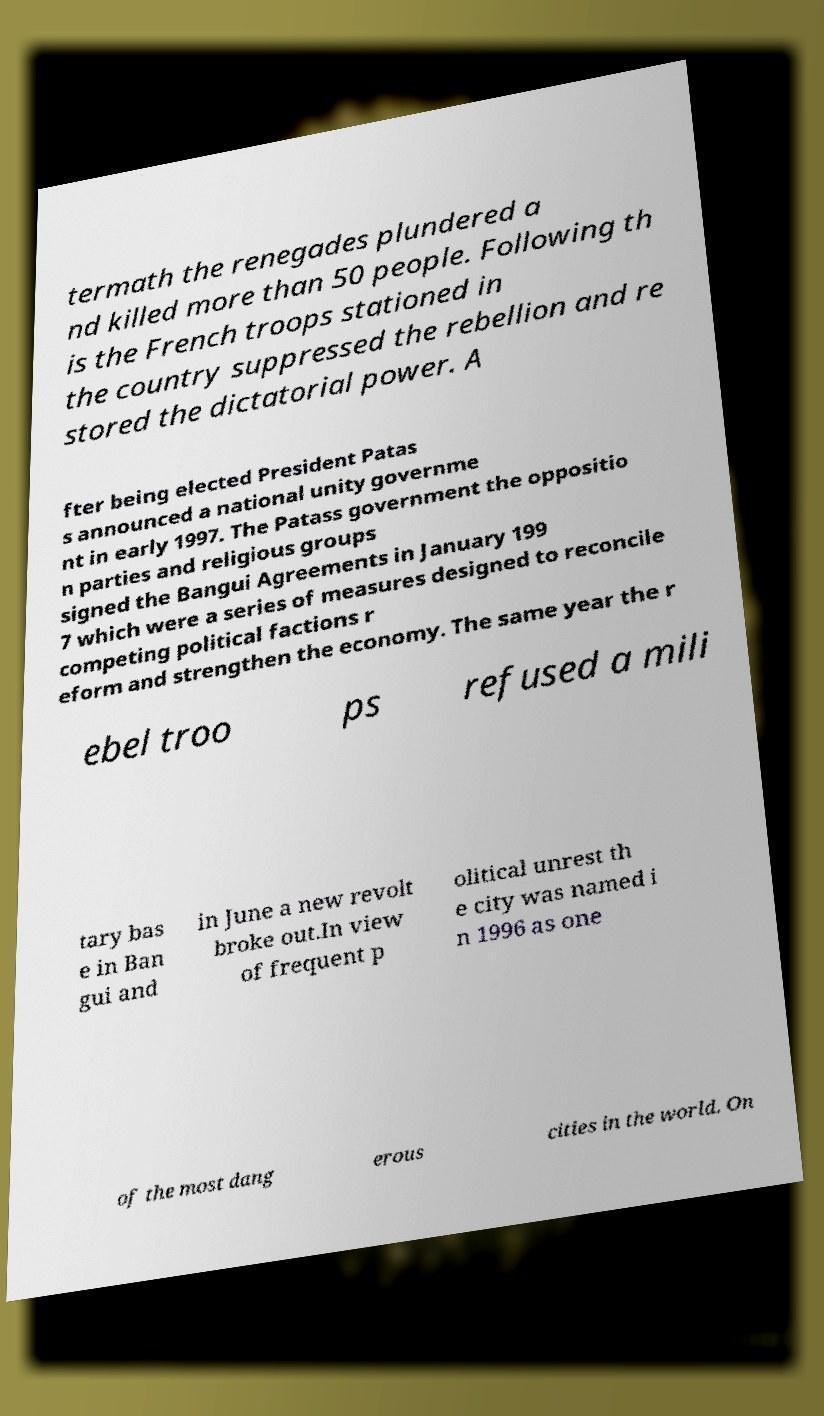There's text embedded in this image that I need extracted. Can you transcribe it verbatim? termath the renegades plundered a nd killed more than 50 people. Following th is the French troops stationed in the country suppressed the rebellion and re stored the dictatorial power. A fter being elected President Patas s announced a national unity governme nt in early 1997. The Patass government the oppositio n parties and religious groups signed the Bangui Agreements in January 199 7 which were a series of measures designed to reconcile competing political factions r eform and strengthen the economy. The same year the r ebel troo ps refused a mili tary bas e in Ban gui and in June a new revolt broke out.In view of frequent p olitical unrest th e city was named i n 1996 as one of the most dang erous cities in the world. On 